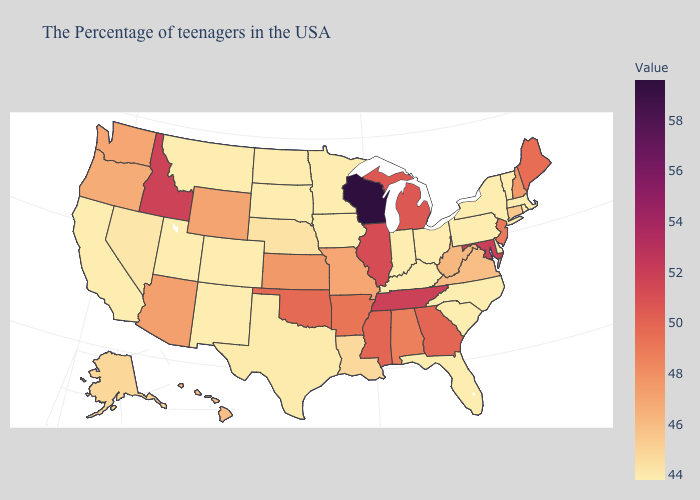Which states hav the highest value in the MidWest?
Quick response, please. Wisconsin. Among the states that border Maryland , which have the highest value?
Short answer required. West Virginia. Does North Carolina have the lowest value in the South?
Write a very short answer. Yes. Which states have the lowest value in the South?
Short answer required. Delaware, North Carolina, South Carolina, Florida, Kentucky. Does the map have missing data?
Write a very short answer. No. Does Kansas have the lowest value in the MidWest?
Be succinct. No. 